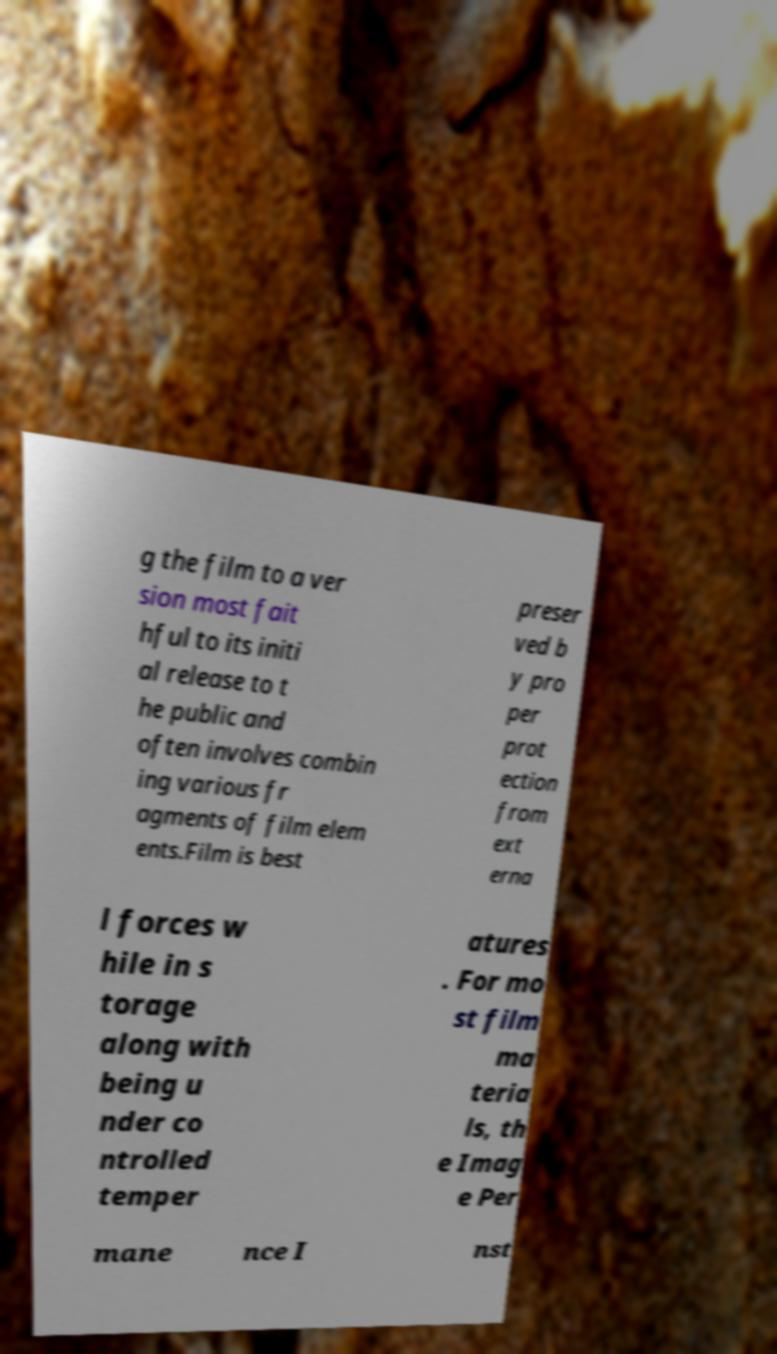There's text embedded in this image that I need extracted. Can you transcribe it verbatim? g the film to a ver sion most fait hful to its initi al release to t he public and often involves combin ing various fr agments of film elem ents.Film is best preser ved b y pro per prot ection from ext erna l forces w hile in s torage along with being u nder co ntrolled temper atures . For mo st film ma teria ls, th e Imag e Per mane nce I nst 